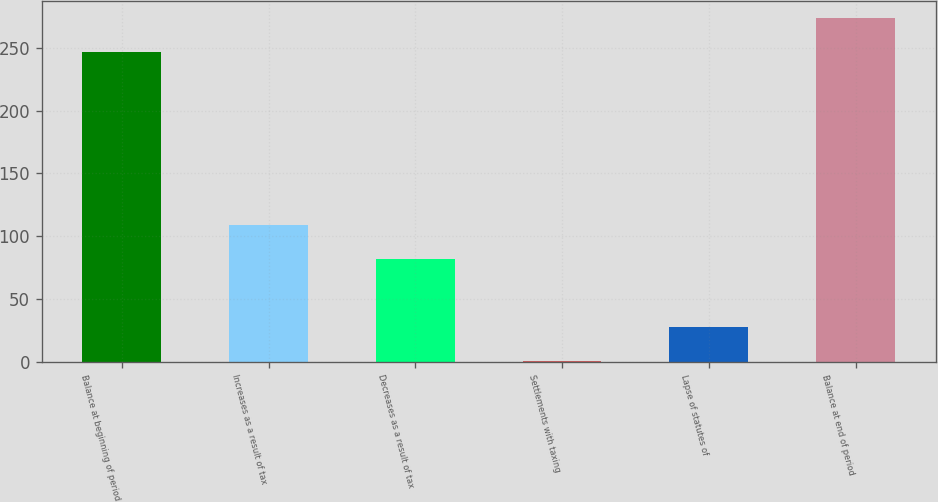Convert chart to OTSL. <chart><loc_0><loc_0><loc_500><loc_500><bar_chart><fcel>Balance at beginning of period<fcel>Increases as a result of tax<fcel>Decreases as a result of tax<fcel>Settlements with taxing<fcel>Lapse of statutes of<fcel>Balance at end of period<nl><fcel>246.7<fcel>109.24<fcel>82.13<fcel>0.8<fcel>27.91<fcel>273.81<nl></chart> 